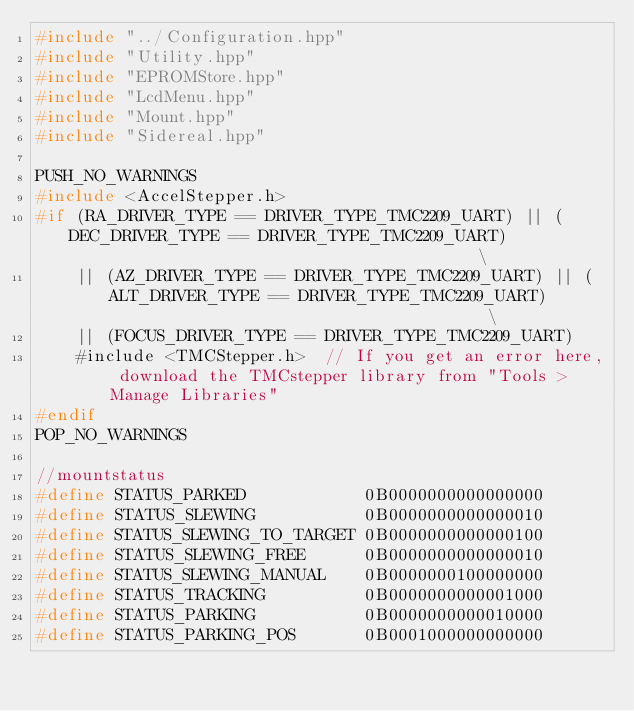Convert code to text. <code><loc_0><loc_0><loc_500><loc_500><_C++_>#include "../Configuration.hpp"
#include "Utility.hpp"
#include "EPROMStore.hpp"
#include "LcdMenu.hpp"
#include "Mount.hpp"
#include "Sidereal.hpp"

PUSH_NO_WARNINGS
#include <AccelStepper.h>
#if (RA_DRIVER_TYPE == DRIVER_TYPE_TMC2209_UART) || (DEC_DRIVER_TYPE == DRIVER_TYPE_TMC2209_UART)                                          \
    || (AZ_DRIVER_TYPE == DRIVER_TYPE_TMC2209_UART) || (ALT_DRIVER_TYPE == DRIVER_TYPE_TMC2209_UART)                                       \
    || (FOCUS_DRIVER_TYPE == DRIVER_TYPE_TMC2209_UART)
    #include <TMCStepper.h>  // If you get an error here, download the TMCstepper library from "Tools > Manage Libraries"
#endif
POP_NO_WARNINGS

//mountstatus
#define STATUS_PARKED            0B0000000000000000
#define STATUS_SLEWING           0B0000000000000010
#define STATUS_SLEWING_TO_TARGET 0B0000000000000100
#define STATUS_SLEWING_FREE      0B0000000000000010
#define STATUS_SLEWING_MANUAL    0B0000000100000000
#define STATUS_TRACKING          0B0000000000001000
#define STATUS_PARKING           0B0000000000010000
#define STATUS_PARKING_POS       0B0001000000000000</code> 